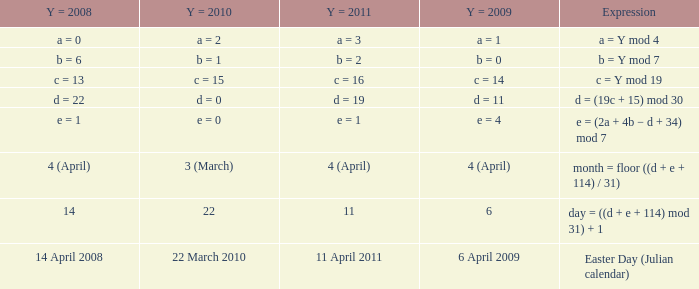What is  the y = 2009 when the expression is month = floor ((d + e + 114) / 31)? 4 (April). 